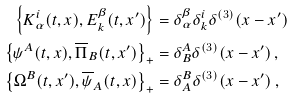<formula> <loc_0><loc_0><loc_500><loc_500>\left \{ K ^ { i } _ { \alpha } ( t , x ) , E ^ { \beta } _ { k } ( t , x ^ { \prime } ) \right \} & = \delta _ { \alpha } ^ { \beta } \delta ^ { i } _ { k } \delta ^ { ( 3 ) } ( x - x ^ { \prime } ) \\ \left \{ \psi ^ { A } ( t , x ) , \overline { \Pi } _ { B } ( t , x ^ { \prime } ) \right \} _ { + } & = \delta ^ { A } _ { B } \delta ^ { ( 3 ) } ( x - x ^ { \prime } ) \, , \\ \left \{ \Omega ^ { B } ( t , x ^ { \prime } ) , \overline { \psi } _ { A } ( t , x ) \right \} _ { + } & = \delta _ { A } ^ { B } \delta ^ { ( 3 ) } ( x - x ^ { \prime } ) \, ,</formula> 